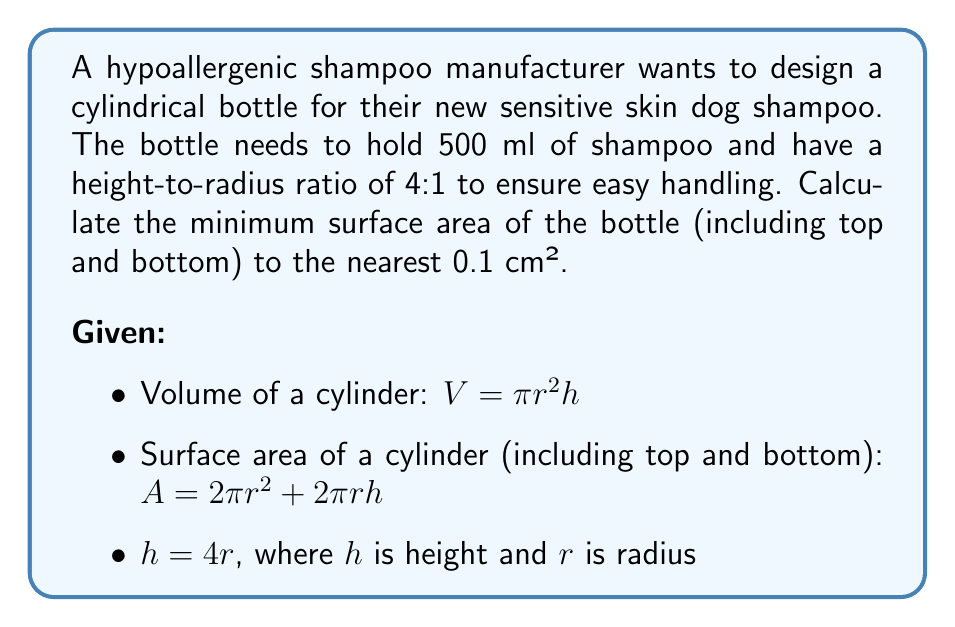Can you solve this math problem? Let's approach this step-by-step:

1) First, we need to find the radius of the cylinder. We can use the volume formula and the given height-to-radius ratio:

   $V = \pi r^2 h = \pi r^2 (4r) = 4\pi r^3$

2) We know the volume is 500 ml = 500 cm³. Let's substitute this:

   $500 = 4\pi r^3$

3) Solving for $r$:

   $r^3 = \frac{500}{4\pi}$
   $r = \sqrt[3]{\frac{500}{4\pi}} \approx 4.205$ cm

4) Now that we have $r$, we can calculate $h$:

   $h = 4r \approx 4(4.205) = 16.82$ cm

5) Now we can use the surface area formula:

   $A = 2\pi r^2 + 2\pi rh$

6) Substituting our values:

   $A = 2\pi (4.205)^2 + 2\pi (4.205)(16.82)$

7) Calculating:

   $A \approx 221.3 + 443.8 = 665.1$ cm²

8) Rounding to the nearest 0.1 cm²:

   $A \approx 665.1$ cm²
Answer: The minimum surface area of the hypoallergenic shampoo bottle is approximately 665.1 cm². 